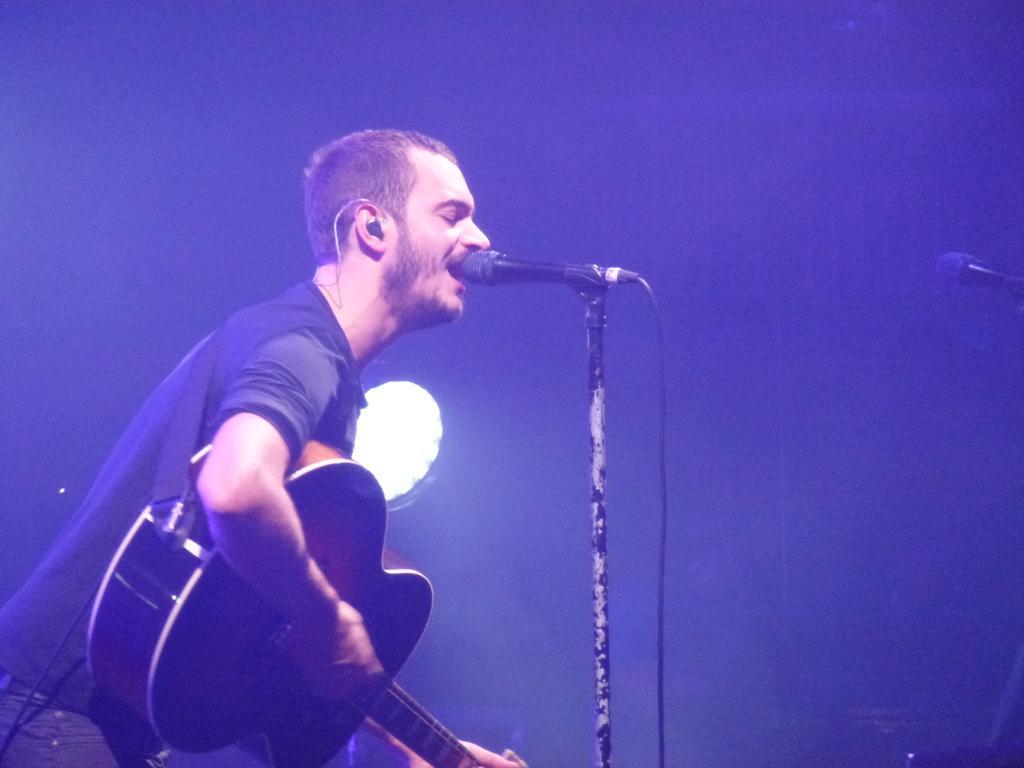Can you describe this image briefly? This person is holding a guitar and singing in-front of a mic. 